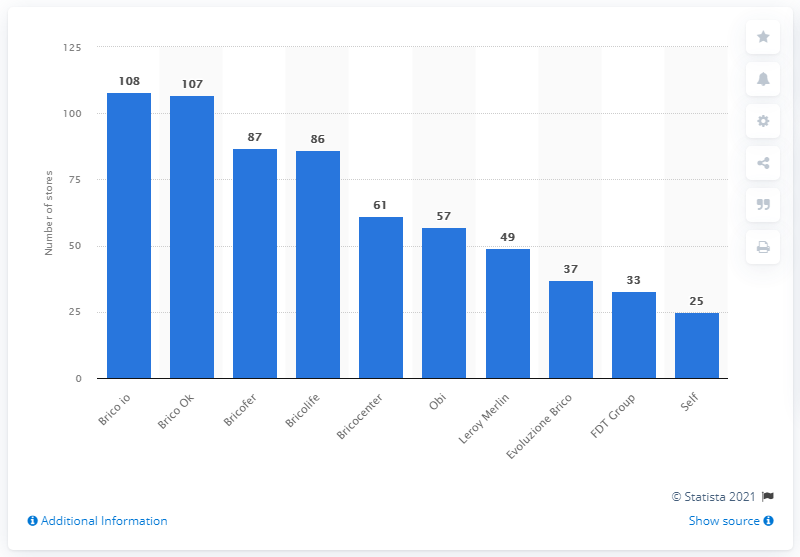Indicate a few pertinent items in this graphic. Bricofer had 87 stores as of [insert date]. In 2020, Brico io had a total of 108 retail stores in Italy. Brico OK is the second largest retailer in Italy in terms of the number of stores. 